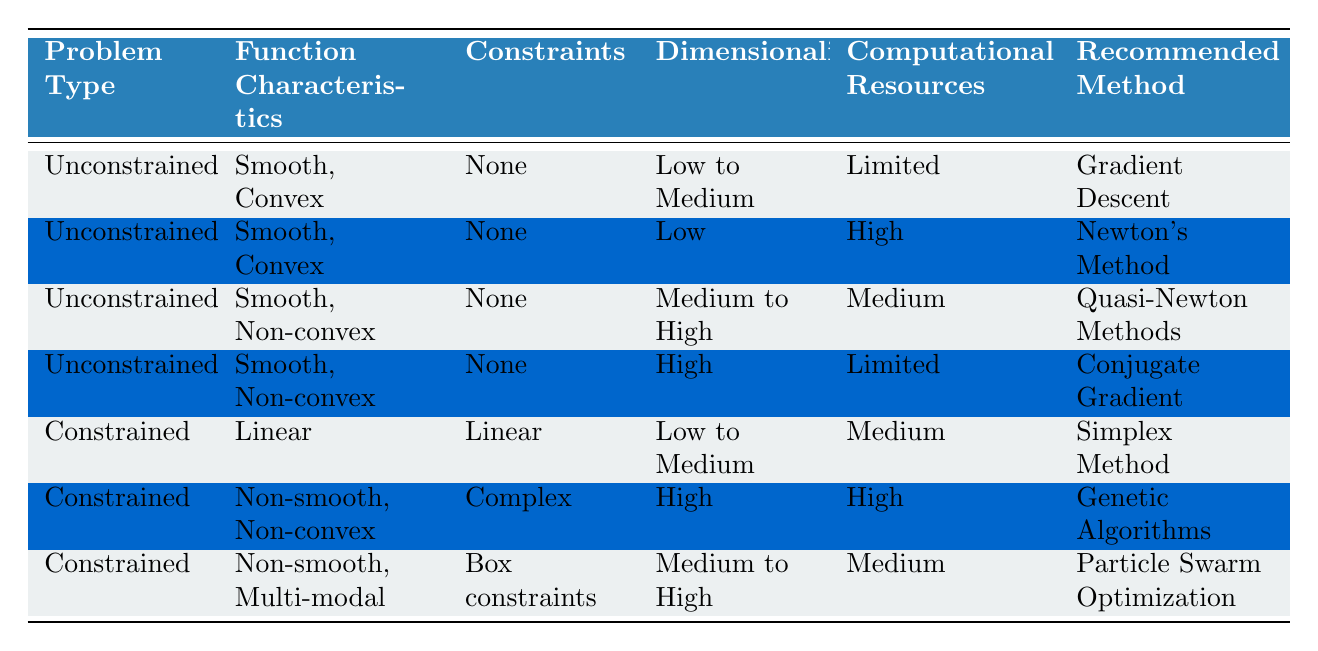What optimization method is recommended for an unconstrained problem with smooth, convex characteristics, limited computational resources, and low to medium dimensionality? The table indicates that for "Unconstrained" problems with "Smooth, Convex" characteristics and "Low to Medium" dimensionality while having "Limited" computational resources, the recommended method is "Gradient Descent".
Answer: Gradient Descent What is the recommended optimization method for constrained problems that have complex constraints and are non-smooth, non-convex, with high dimensionality and high computational resources? According to the table, for "Constrained" problems that are "Non-smooth, Non-convex" with "Complex" constraints, "High" dimensionality, and "High" computational resources, the recommended method is "Genetic Algorithms".
Answer: Genetic Algorithms Are all recommended methods for unconstrained problems based on smooth function characteristics? The table displays data for unconstrained problems indicating two sets of function characteristics: one for "Smooth, Convex" and another for "Smooth, Non-convex". Therefore, not all recommended methods for unconstrained problems are based on smooth function characteristics; some methods also apply to non-convex problems.
Answer: No What is the total number of optimization methods listed for constrained problems and unconstrained problems? From the table, there are three optimization methods for constrained problems: Simplex Method, Genetic Algorithms, and Particle Swarm Optimization. For unconstrained problems, there are four methods: Gradient Descent, Newton's Method, Quasi-Newton Methods, and Conjugate Gradient. Hence, the total is 3 + 4 = 7 methods.
Answer: 7 Which optimization method is recommended for low dimensionality, linear constrained problems involving linear constraints with medium computational resources? The table specifically mentions that for "Constrained" problems categorized as "Linear" with "Linear" constraints and "Low to Medium" dimensionality along with "Medium" computational resources, the recommended method is "Simplex Method".
Answer: Simplex Method Can a constrained problem with high dimensionality and limited computational resources have a recommended method? Based on the table, it shows that for "Constrained" problems to exist with "High" dimensionality, there is an associated recommended method—Genetic Algorithms, which requires "High" computational resources. Therefore, a constrained problem with high dimensionality typically cannot be effectively solved with limited resources according to the data.
Answer: No What are the characteristics of the recommended optimization method for unconstrained problems that are smooth and non-convex with high dimensionality? The information from the table states that for unconstrained problems characterized as "Smooth, Non-convex" with "High" dimensionality and "Limited" computational resources, the recommended optimization method is "Conjugate Gradient".
Answer: Conjugate Gradient In how many rows of the table is the optimization method "Particle Swarm Optimization" recommended? Upon examining the table, "Particle Swarm Optimization" appears in one row, specifically for constrained problems focused on non-smooth, multi-modal scenarios with "Medium to High" dimensionality and "Medium" computational resources.
Answer: 1 